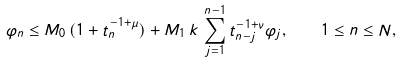<formula> <loc_0><loc_0><loc_500><loc_500>\varphi _ { n } \leq M _ { 0 } \, ( 1 + t _ { n } ^ { - 1 + \mu } ) + M _ { 1 } \, k \, \sum _ { j = 1 } ^ { n - 1 } t _ { n - j } ^ { - 1 + \nu } \varphi _ { j } , \quad 1 \leq n \leq N ,</formula> 